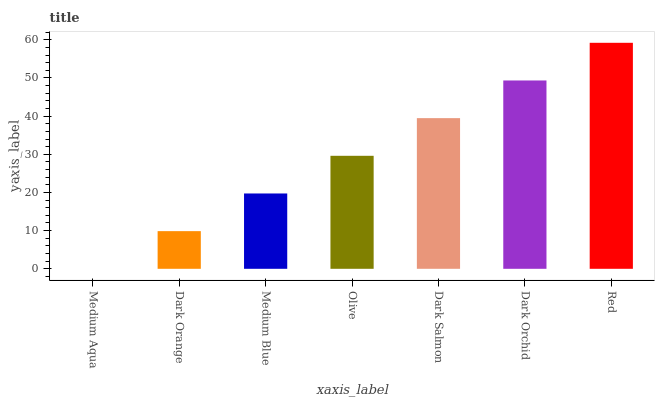Is Medium Aqua the minimum?
Answer yes or no. Yes. Is Red the maximum?
Answer yes or no. Yes. Is Dark Orange the minimum?
Answer yes or no. No. Is Dark Orange the maximum?
Answer yes or no. No. Is Dark Orange greater than Medium Aqua?
Answer yes or no. Yes. Is Medium Aqua less than Dark Orange?
Answer yes or no. Yes. Is Medium Aqua greater than Dark Orange?
Answer yes or no. No. Is Dark Orange less than Medium Aqua?
Answer yes or no. No. Is Olive the high median?
Answer yes or no. Yes. Is Olive the low median?
Answer yes or no. Yes. Is Dark Salmon the high median?
Answer yes or no. No. Is Red the low median?
Answer yes or no. No. 